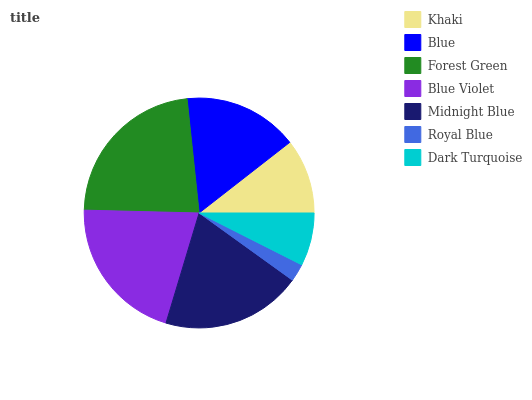Is Royal Blue the minimum?
Answer yes or no. Yes. Is Forest Green the maximum?
Answer yes or no. Yes. Is Blue the minimum?
Answer yes or no. No. Is Blue the maximum?
Answer yes or no. No. Is Blue greater than Khaki?
Answer yes or no. Yes. Is Khaki less than Blue?
Answer yes or no. Yes. Is Khaki greater than Blue?
Answer yes or no. No. Is Blue less than Khaki?
Answer yes or no. No. Is Blue the high median?
Answer yes or no. Yes. Is Blue the low median?
Answer yes or no. Yes. Is Midnight Blue the high median?
Answer yes or no. No. Is Royal Blue the low median?
Answer yes or no. No. 